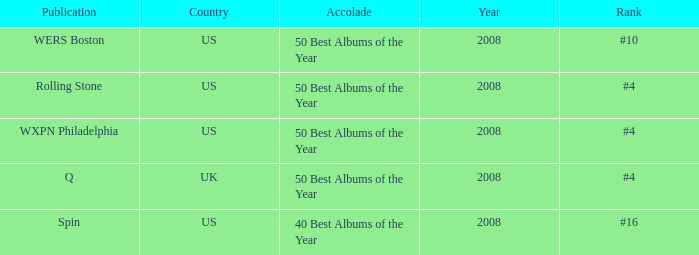Which rank's country is the US when the accolade is 40 best albums of the year? #16. 